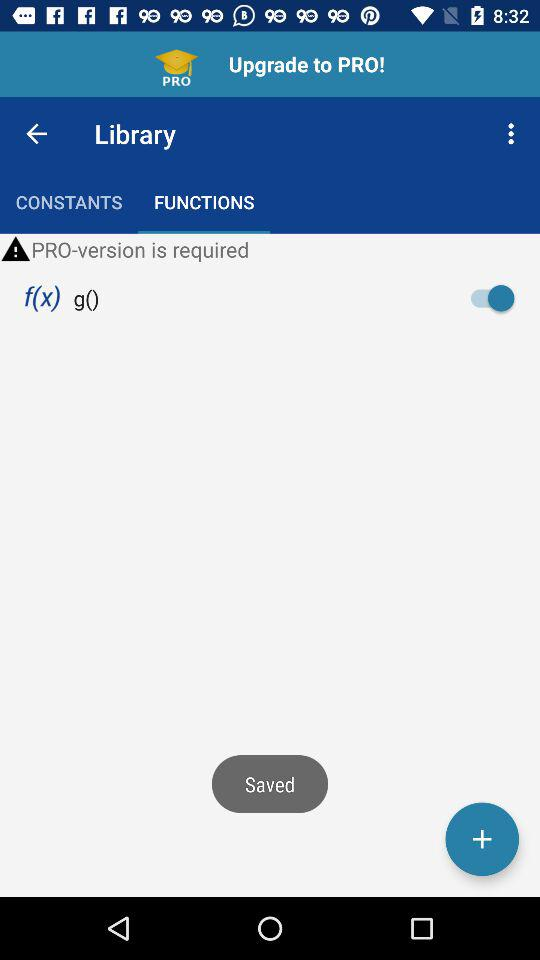Which tab is selected in the "Library"? The selected tab is "FUNCTIONS". 